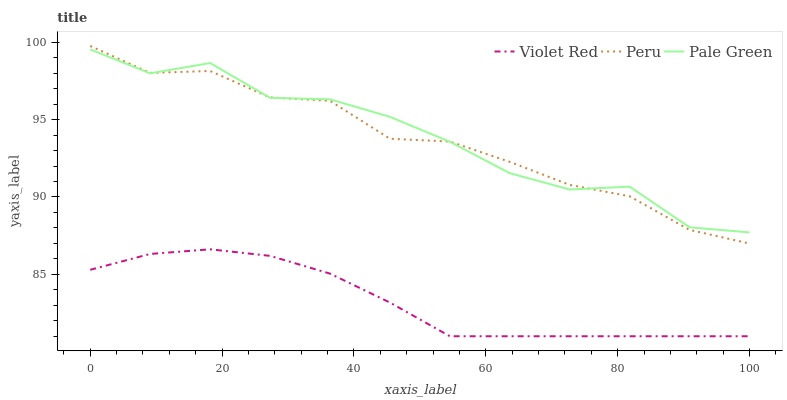Does Violet Red have the minimum area under the curve?
Answer yes or no. Yes. Does Pale Green have the maximum area under the curve?
Answer yes or no. Yes. Does Peru have the minimum area under the curve?
Answer yes or no. No. Does Peru have the maximum area under the curve?
Answer yes or no. No. Is Violet Red the smoothest?
Answer yes or no. Yes. Is Pale Green the roughest?
Answer yes or no. Yes. Is Peru the smoothest?
Answer yes or no. No. Is Peru the roughest?
Answer yes or no. No. Does Peru have the lowest value?
Answer yes or no. No. Does Peru have the highest value?
Answer yes or no. Yes. Does Pale Green have the highest value?
Answer yes or no. No. Is Violet Red less than Pale Green?
Answer yes or no. Yes. Is Pale Green greater than Violet Red?
Answer yes or no. Yes. Does Peru intersect Pale Green?
Answer yes or no. Yes. Is Peru less than Pale Green?
Answer yes or no. No. Is Peru greater than Pale Green?
Answer yes or no. No. Does Violet Red intersect Pale Green?
Answer yes or no. No. 